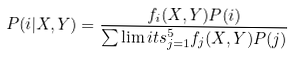<formula> <loc_0><loc_0><loc_500><loc_500>P ( i | X , Y ) = \frac { f _ { i } ( X , Y ) P ( i ) } { \sum \lim i t s _ { j = 1 } ^ { 5 } f _ { j } ( X , Y ) P ( j ) }</formula> 